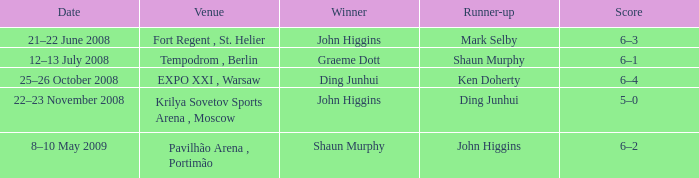Who was the winner in the match that had John Higgins as runner-up? Shaun Murphy. 